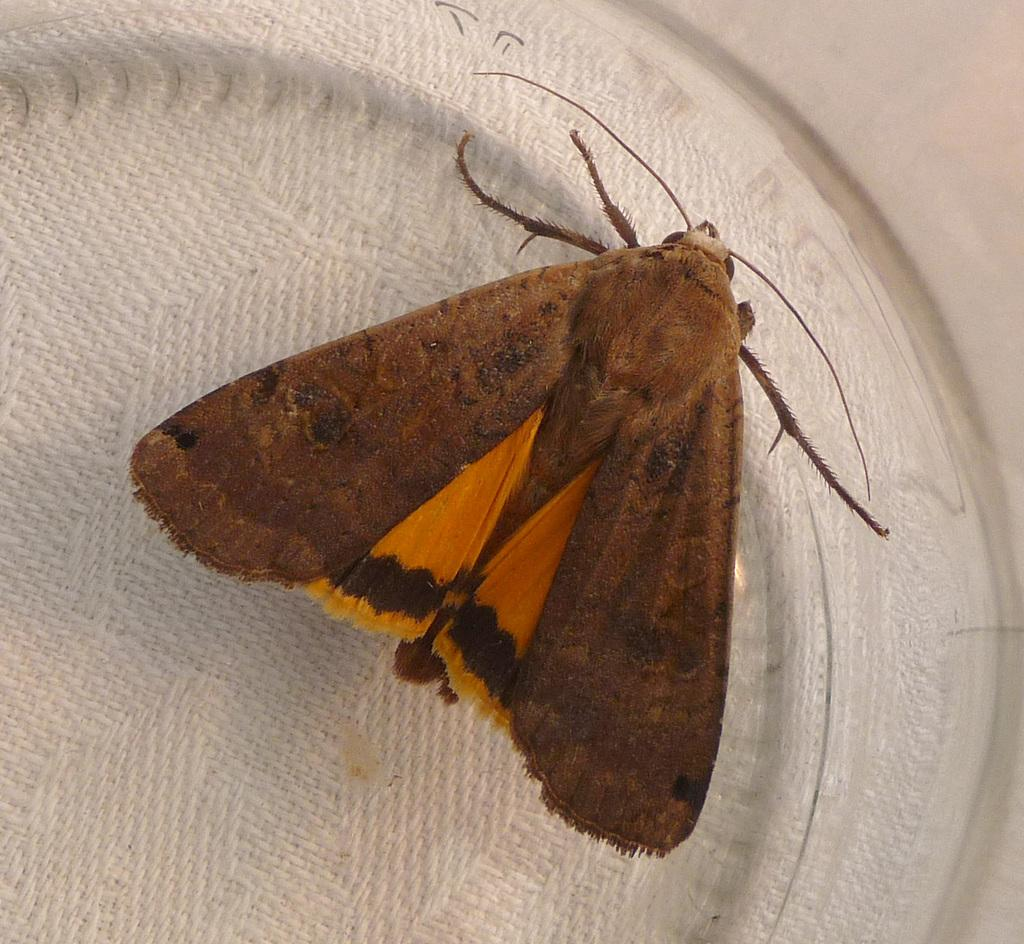What is the main subject of the image? The main subject of the image is a butterfly. What colors can be seen on the butterfly? The butterfly has brown and yellow colors. What is the background or surface on which the butterfly is resting? The butterfly is on a white surface. What type of manager is overseeing the operations at the airport in the image? There is no manager or airport present in the image; it features a butterfly on a white surface. 